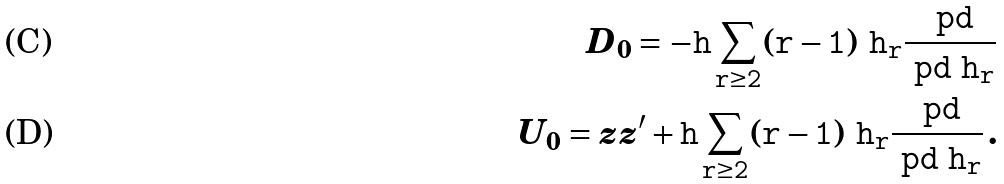Convert formula to latex. <formula><loc_0><loc_0><loc_500><loc_500>D _ { 0 } = - \tt h \sum _ { r \geq 2 } ( r - 1 ) \ h _ { r } \frac { \ p d } { \ p d \ h _ { r } } \\ U _ { 0 } = z z ^ { \prime } + \tt h \sum _ { r \geq 2 } ( r - 1 ) \ h _ { r } \frac { \ p d } { \ p d \ h _ { r } } \, .</formula> 